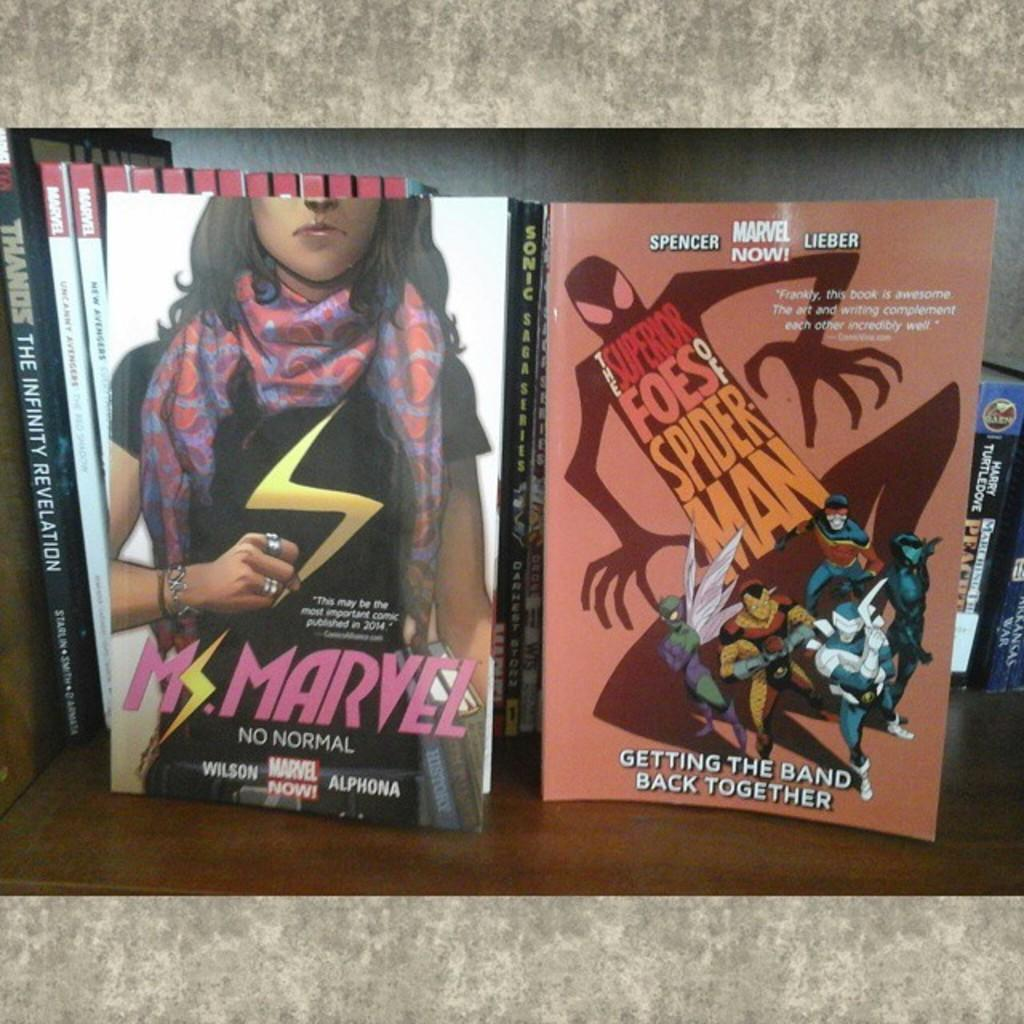<image>
Present a compact description of the photo's key features. A Ms. Marvel comic and a Spiderman comic on a shelf. 